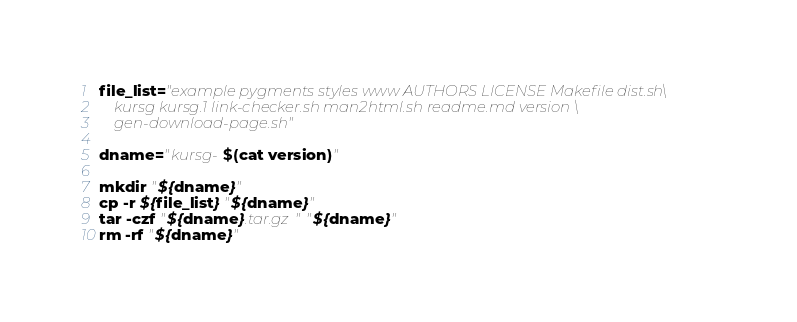Convert code to text. <code><loc_0><loc_0><loc_500><loc_500><_Bash_>
file_list="example pygments styles www AUTHORS LICENSE Makefile dist.sh\
    kursg kursg.1 link-checker.sh man2html.sh readme.md version \
    gen-download-page.sh"

dname="kursg-$(cat version)"

mkdir "${dname}"
cp -r ${file_list} "${dname}"
tar -czf "${dname}.tar.gz" "${dname}"
rm -rf "${dname}"
</code> 